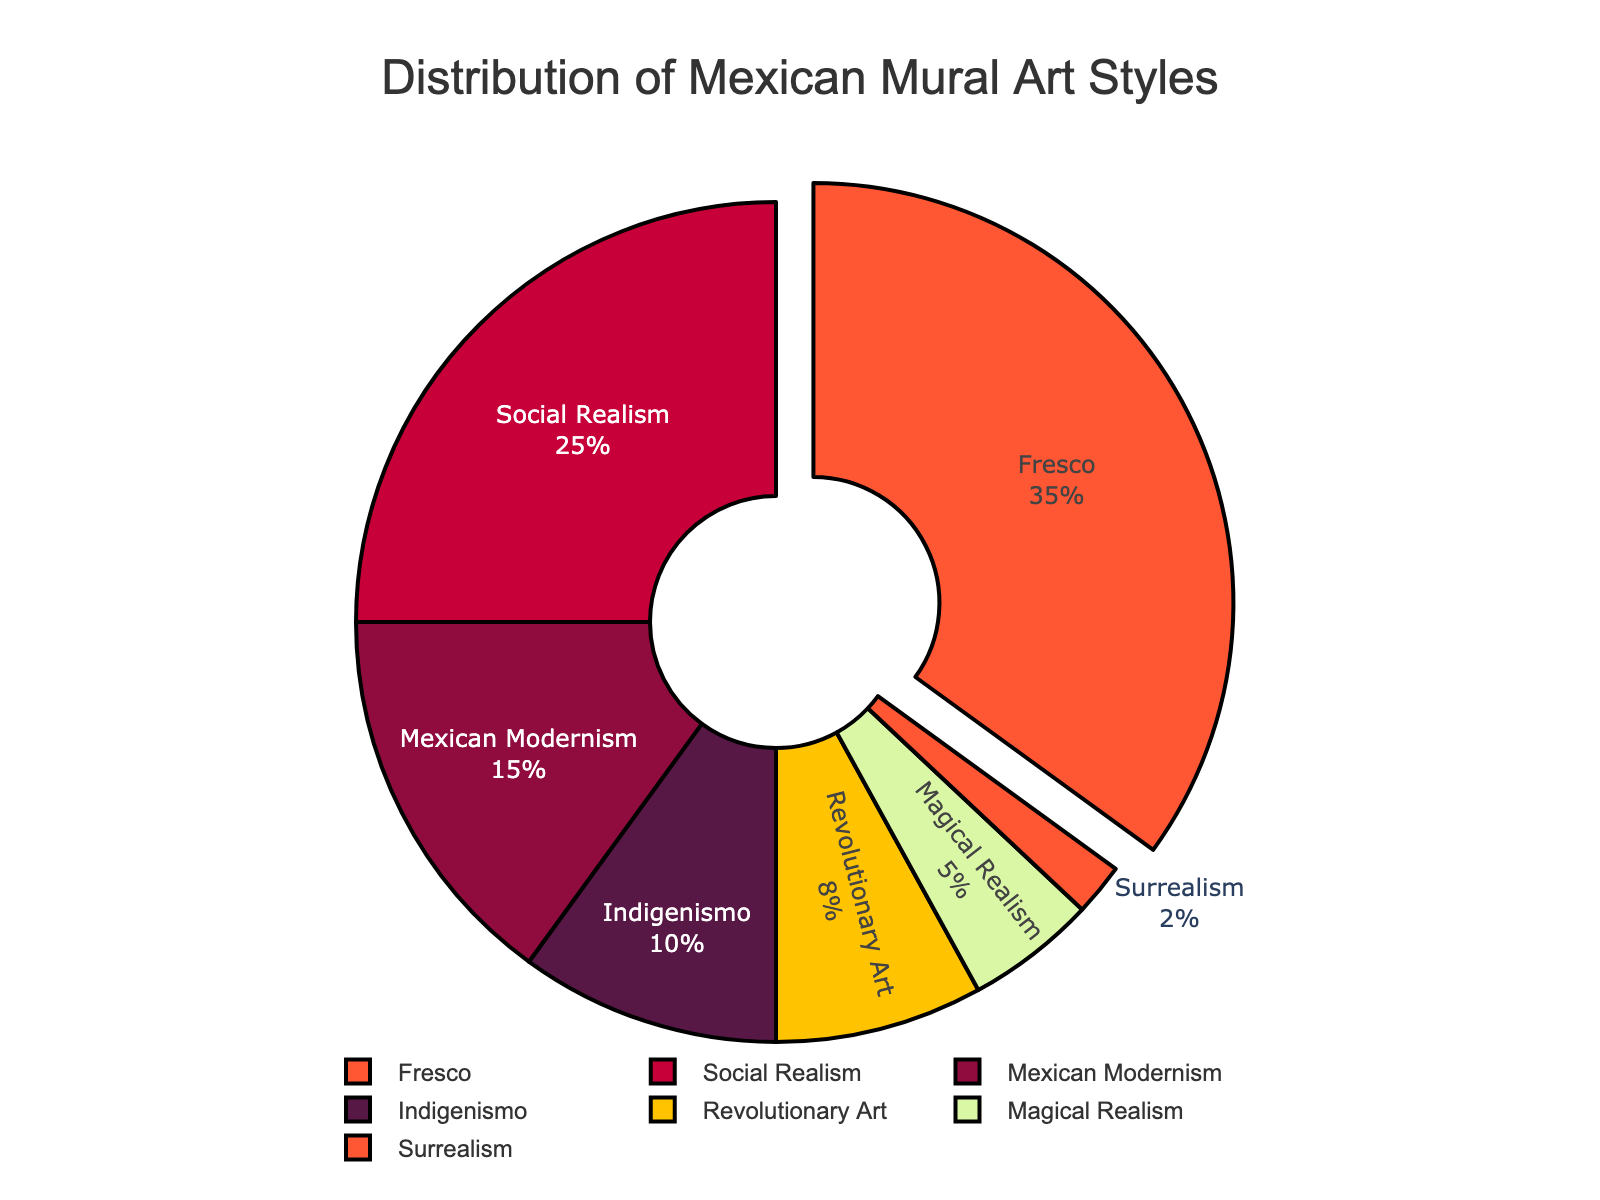What is the most taught Mexican mural art style in the classes? The figure shows a pie chart with various Mexican mural art styles. The largest segment, which is also pulled out, represents the style with the highest percentage. In this case, "Fresco" represents 35% of the total.
Answer: Fresco How much larger is the percentage of Fresco compared to Social Realism? According to the pie chart, Fresco makes up 35% and Social Realism makes up 25%. Subtracting these values, 35% - 25% gives the difference.
Answer: 10% What is the combined percentage of Mexican Modernism and Indigenismo? The pie chart shows Mexican Modernism at 15% and Indigenismo at 10%. Adding these values together gives 15% + 10%.
Answer: 25% Which style has the smallest representation in the classes? The smallest segment of the pie chart represents the style with the lowest percentage. The chart shows that Surrealism takes up the smallest segment at 2%.
Answer: Surrealism What is the total percentage of Revolutionary Art, Magical Realism, and Surrealism combined? Revolutionary Art is 8%, Magical Realism is 5%, and Surrealism is 2%. Adding these percentages together gives 8% + 5% + 2%.
Answer: 15% Does the sum of Social Realism and Mexican Modernism equal the sum of Indigenismo and Revolutionary Art? Social Realism is 25% and Mexican Modernism is 15%, summing to 40%. Indigenismo is 10% and Revolutionary Art is 8%, summing to 18%. 40% does not equal 18%.
Answer: No Is the percentage of fresco bigger or smaller than the sum of Indigenismo and Magical Realism? Fresco is 35%. The sum of Indigenismo (10%) and Magical Realism (5%) is 15%. 35% is greater than 15%.
Answer: Bigger How many styles have a percentage greater than 10%? By looking at the pie chart, we can see Fresco (35%), Social Realism (25%), and Mexican Modernism (15%) have percentages greater than 10%. Thus, there are 3 styles.
Answer: 3 What is the sum of percentages for all art styles? Adding all percentages given: Fresco (35%), Social Realism (25%), Mexican Modernism (15%), Indigenismo (10%), Revolutionary Art (8%), Magical Realism (5%), Surrealism (2%). The total is 35% + 25% + 15% + 10% + 8% + 5% + 2%.
Answer: 100% 